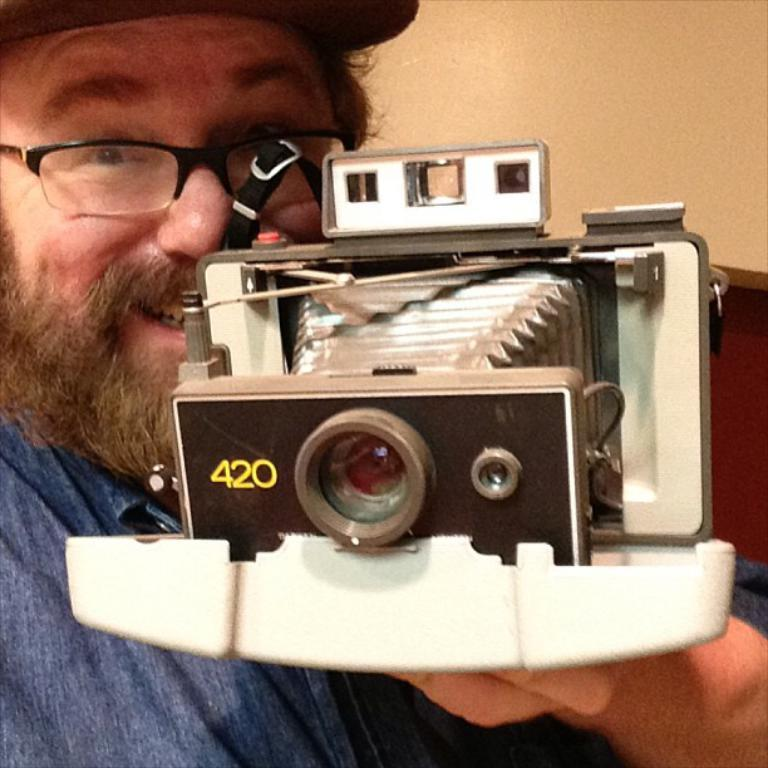Who is present in the image? There is a man in the image. What is the man doing in the image? The man is smiling in the image. What accessories is the man wearing in the image? The man is wearing spectacles and a cap in the image. What is the man holding in the image? The man is holding a camera in his hands in the image. What type of alley can be seen in the background of the image? There is no alley present in the image; it only features a man with accessories and a camera. 